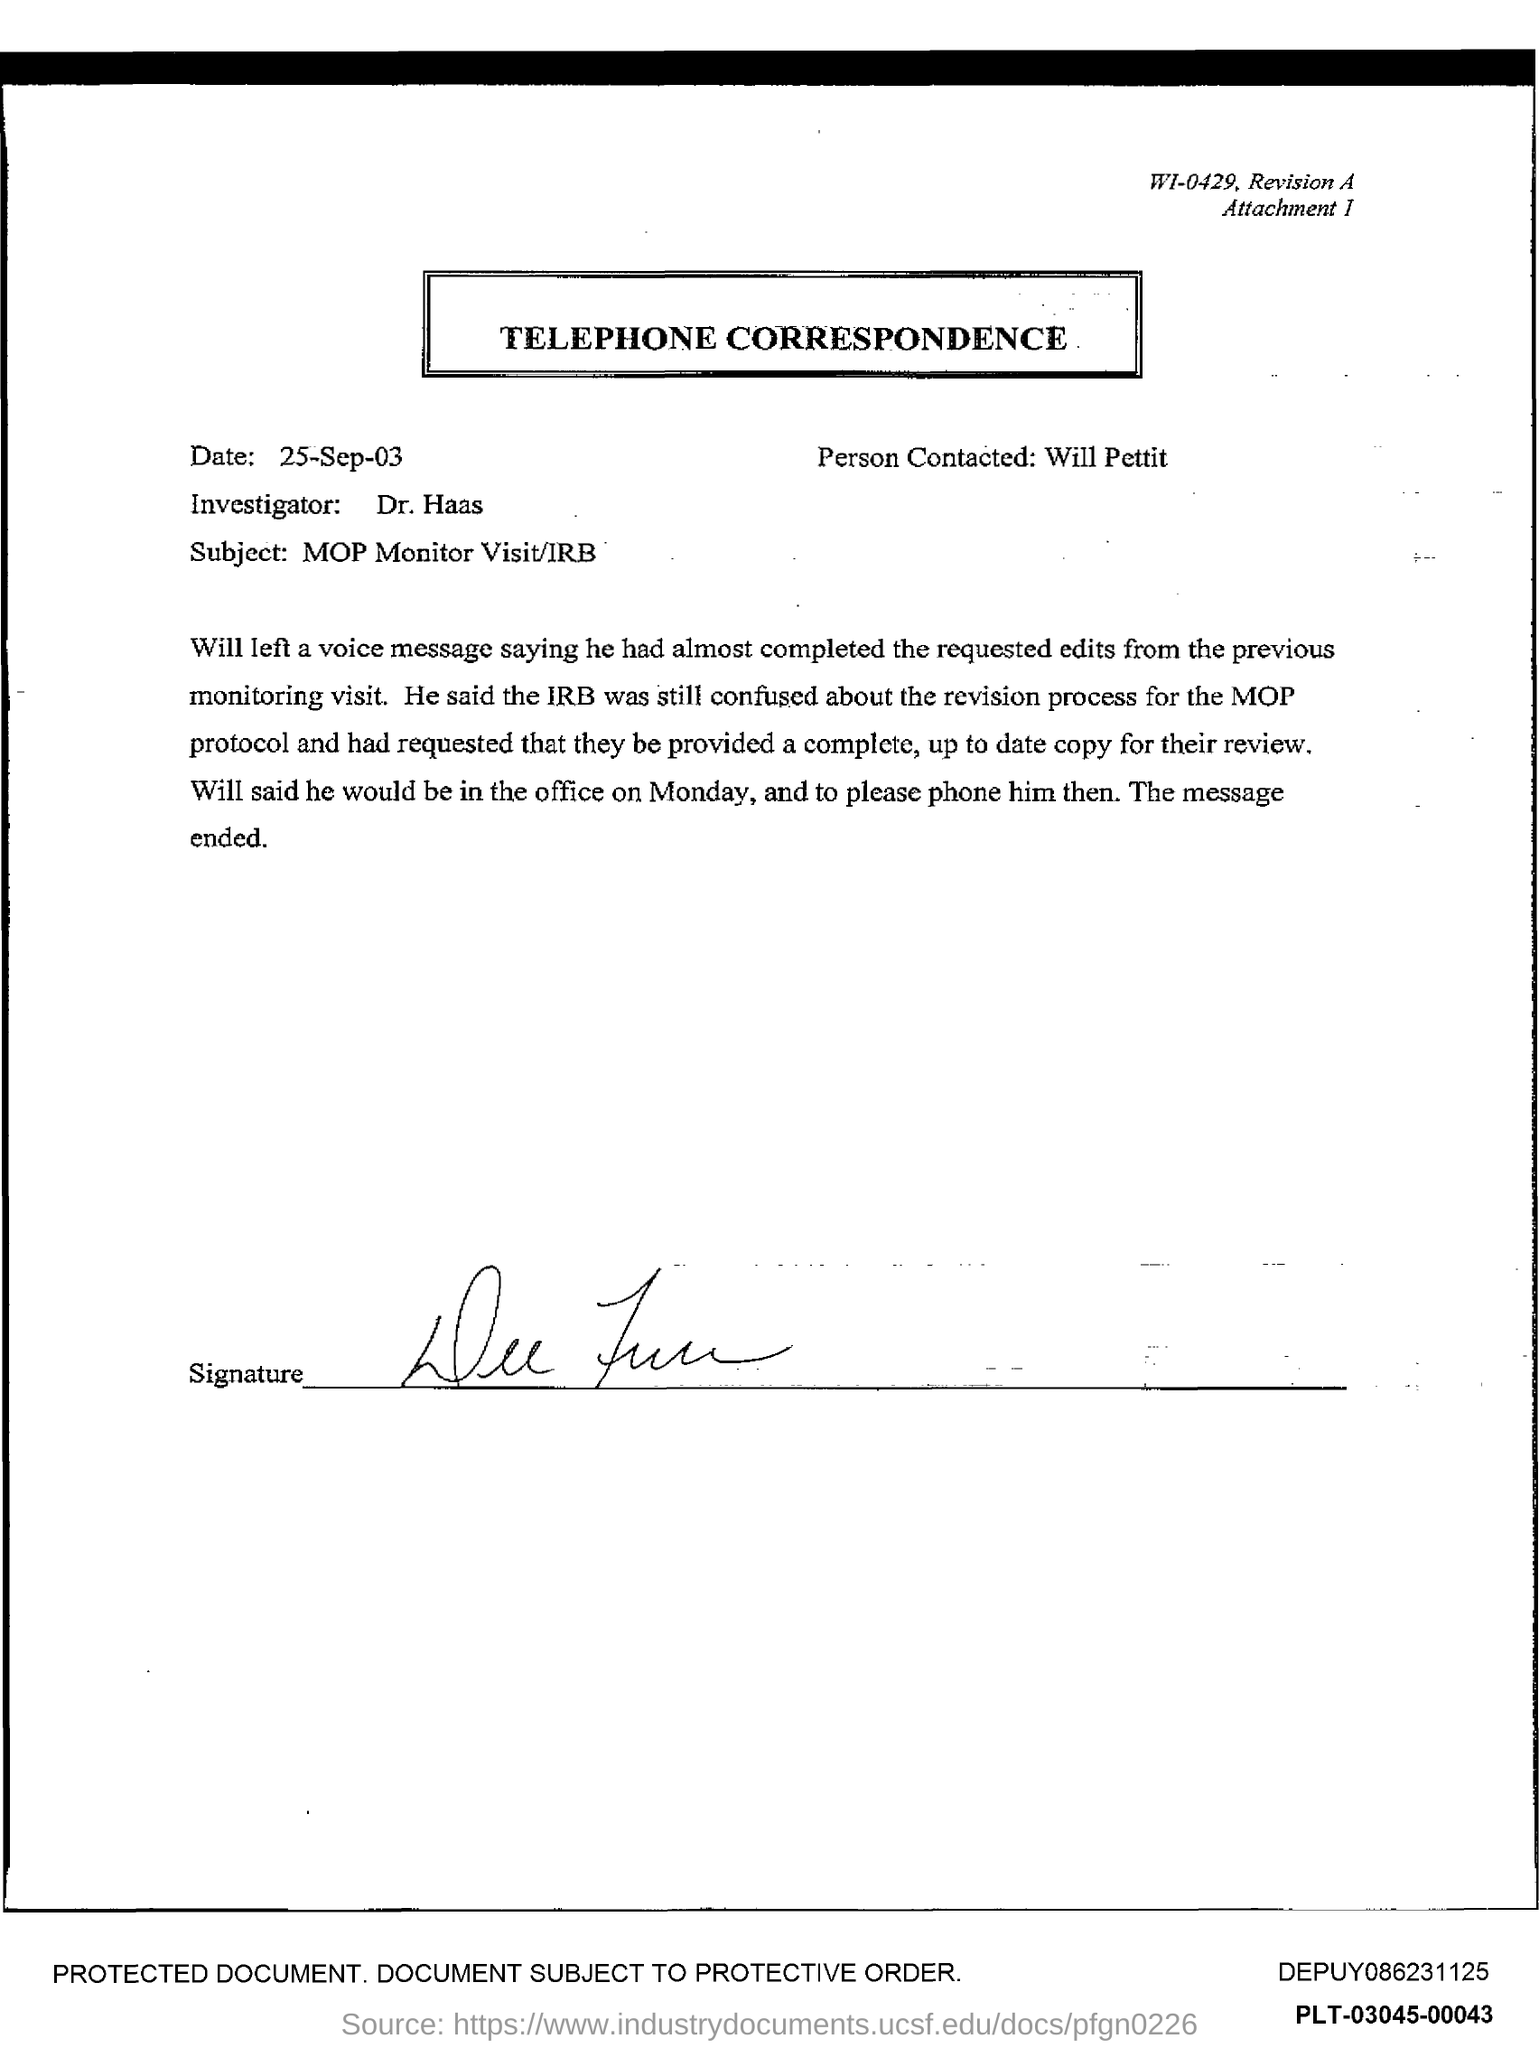What is the name of the person contacted ?
Offer a terse response. Will pettit. What is the date at top of the page?
Provide a succinct answer. 25-Sep-03. 